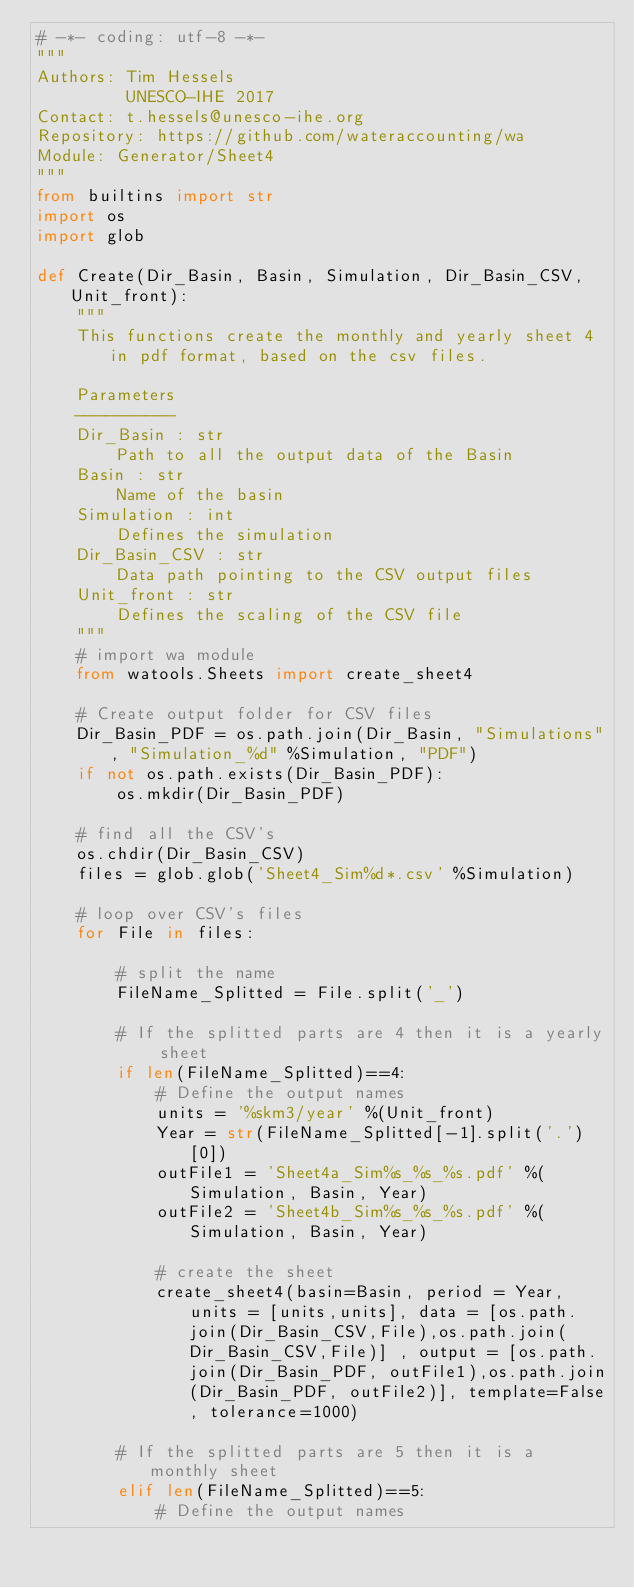<code> <loc_0><loc_0><loc_500><loc_500><_Python_># -*- coding: utf-8 -*-
"""
Authors: Tim Hessels
         UNESCO-IHE 2017
Contact: t.hessels@unesco-ihe.org
Repository: https://github.com/wateraccounting/wa
Module: Generator/Sheet4
"""
from builtins import str
import os
import glob

def Create(Dir_Basin, Basin, Simulation, Dir_Basin_CSV, Unit_front):
    """
    This functions create the monthly and yearly sheet 4 in pdf format, based on the csv files.

    Parameters
    ----------
    Dir_Basin : str
        Path to all the output data of the Basin
    Basin : str
        Name of the basin
    Simulation : int
        Defines the simulation
    Dir_Basin_CSV : str
        Data path pointing to the CSV output files
    Unit_front : str
        Defines the scaling of the CSV file
    """
    # import wa module
    from watools.Sheets import create_sheet4

    # Create output folder for CSV files
    Dir_Basin_PDF = os.path.join(Dir_Basin, "Simulations", "Simulation_%d" %Simulation, "PDF")
    if not os.path.exists(Dir_Basin_PDF):
        os.mkdir(Dir_Basin_PDF)

    # find all the CSV's
    os.chdir(Dir_Basin_CSV)
    files = glob.glob('Sheet4_Sim%d*.csv' %Simulation)

    # loop over CSV's files
    for File in files:

        # split the name
        FileName_Splitted = File.split('_')

        # If the splitted parts are 4 then it is a yearly sheet
        if len(FileName_Splitted)==4:
            # Define the output names
            units = '%skm3/year' %(Unit_front)
            Year = str(FileName_Splitted[-1].split('.')[0])
            outFile1 = 'Sheet4a_Sim%s_%s_%s.pdf' %(Simulation, Basin, Year)
            outFile2 = 'Sheet4b_Sim%s_%s_%s.pdf' %(Simulation, Basin, Year)

            # create the sheet
            create_sheet4(basin=Basin, period = Year, units = [units,units], data = [os.path.join(Dir_Basin_CSV,File),os.path.join(Dir_Basin_CSV,File)] , output = [os.path.join(Dir_Basin_PDF, outFile1),os.path.join(Dir_Basin_PDF, outFile2)], template=False, tolerance=1000)

        # If the splitted parts are 5 then it is a monthly sheet
        elif len(FileName_Splitted)==5:
            # Define the output names</code> 